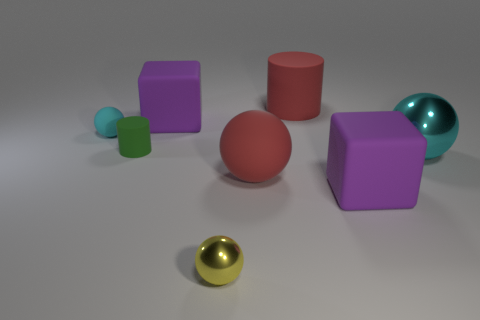Subtract 1 spheres. How many spheres are left? 3 Add 2 small yellow balls. How many objects exist? 10 Subtract all cylinders. How many objects are left? 6 Add 3 big cylinders. How many big cylinders are left? 4 Add 3 tiny matte cylinders. How many tiny matte cylinders exist? 4 Subtract 0 blue balls. How many objects are left? 8 Subtract all tiny red metal objects. Subtract all large purple things. How many objects are left? 6 